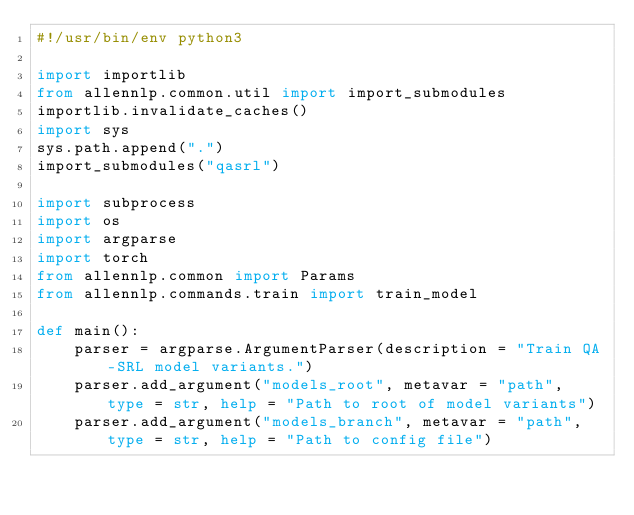<code> <loc_0><loc_0><loc_500><loc_500><_Python_>#!/usr/bin/env python3

import importlib
from allennlp.common.util import import_submodules
importlib.invalidate_caches()
import sys
sys.path.append(".")
import_submodules("qasrl")

import subprocess
import os
import argparse
import torch
from allennlp.common import Params
from allennlp.commands.train import train_model

def main():
    parser = argparse.ArgumentParser(description = "Train QA-SRL model variants.")
    parser.add_argument("models_root", metavar = "path", type = str, help = "Path to root of model variants")
    parser.add_argument("models_branch", metavar = "path", type = str, help = "Path to config file")</code> 